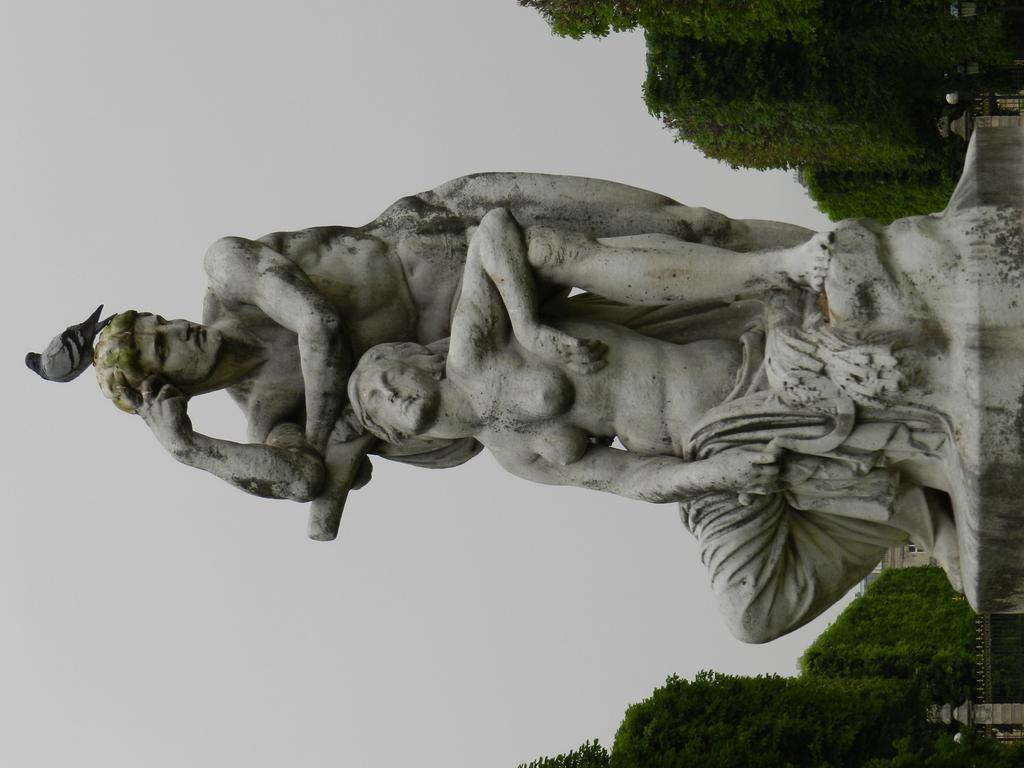What is the main subject in the foreground of the image? There is a sculpture in the foreground of the image. Can you describe any additional details about the sculpture? A bird is present on the sculpture. What can be seen in the background of the image? There are trees, a building, and the sky visible in the background of the image. What type of mitten is the secretary using to hold the hook in the image? There is no secretary, mitten, or hook present in the image. 